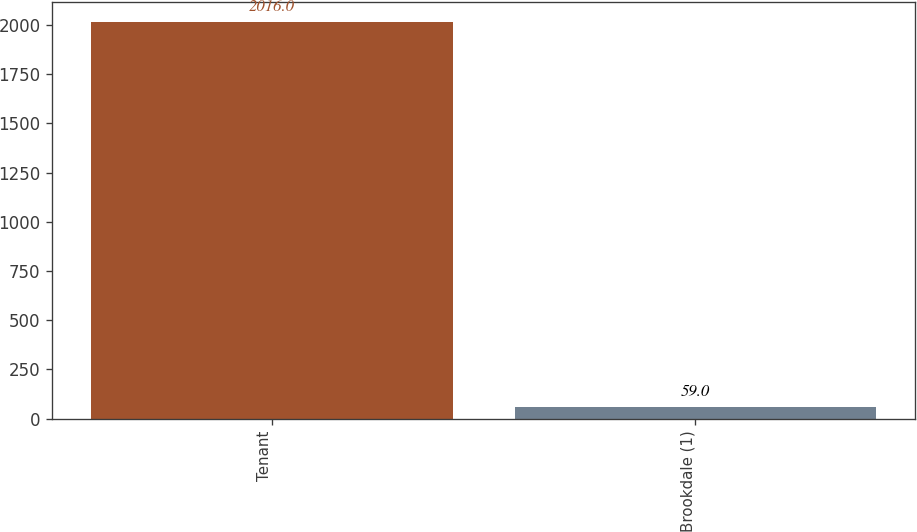Convert chart. <chart><loc_0><loc_0><loc_500><loc_500><bar_chart><fcel>Tenant<fcel>Brookdale (1)<nl><fcel>2016<fcel>59<nl></chart> 